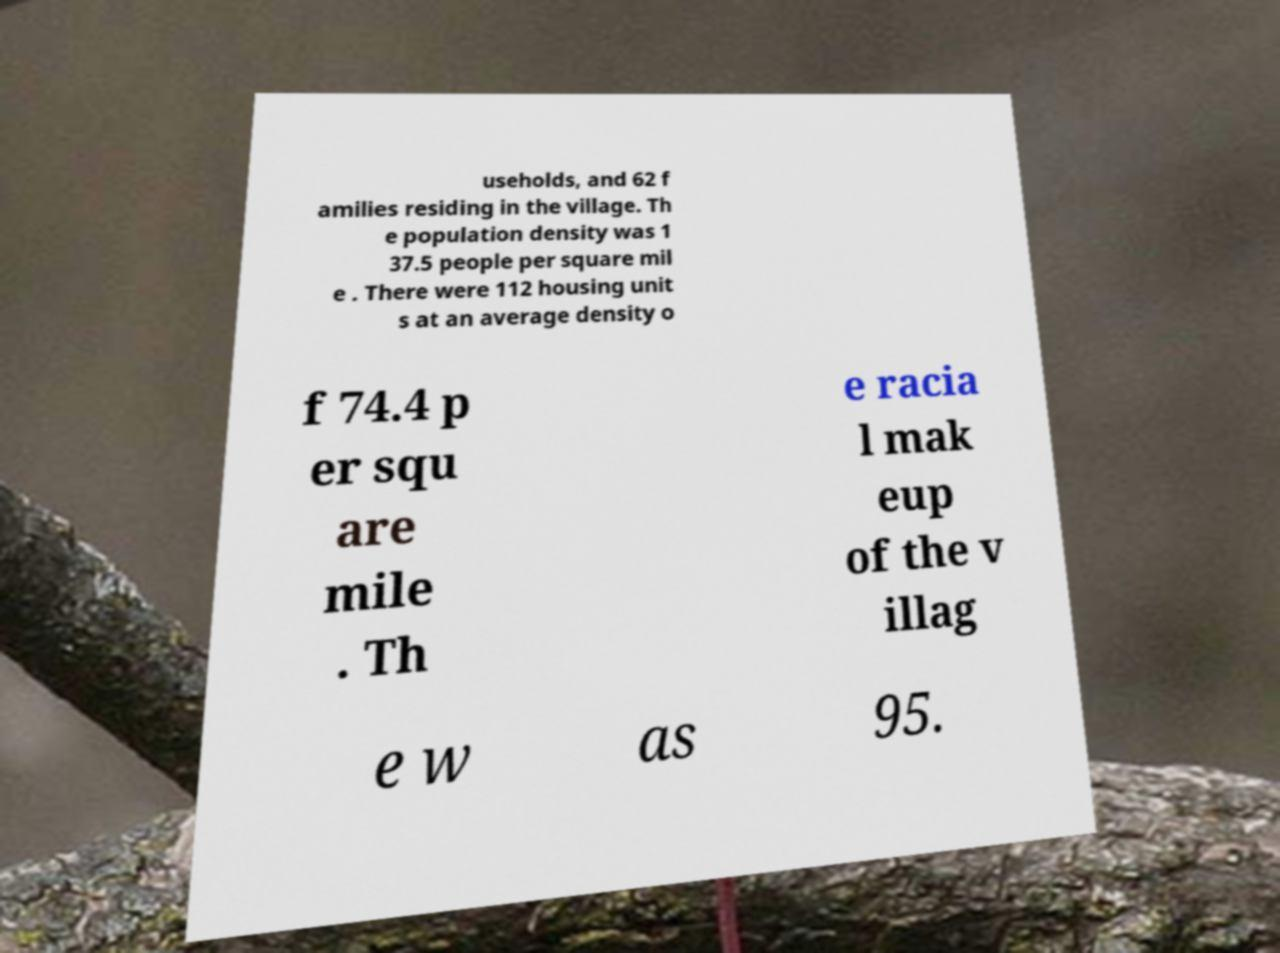Can you read and provide the text displayed in the image?This photo seems to have some interesting text. Can you extract and type it out for me? useholds, and 62 f amilies residing in the village. Th e population density was 1 37.5 people per square mil e . There were 112 housing unit s at an average density o f 74.4 p er squ are mile . Th e racia l mak eup of the v illag e w as 95. 